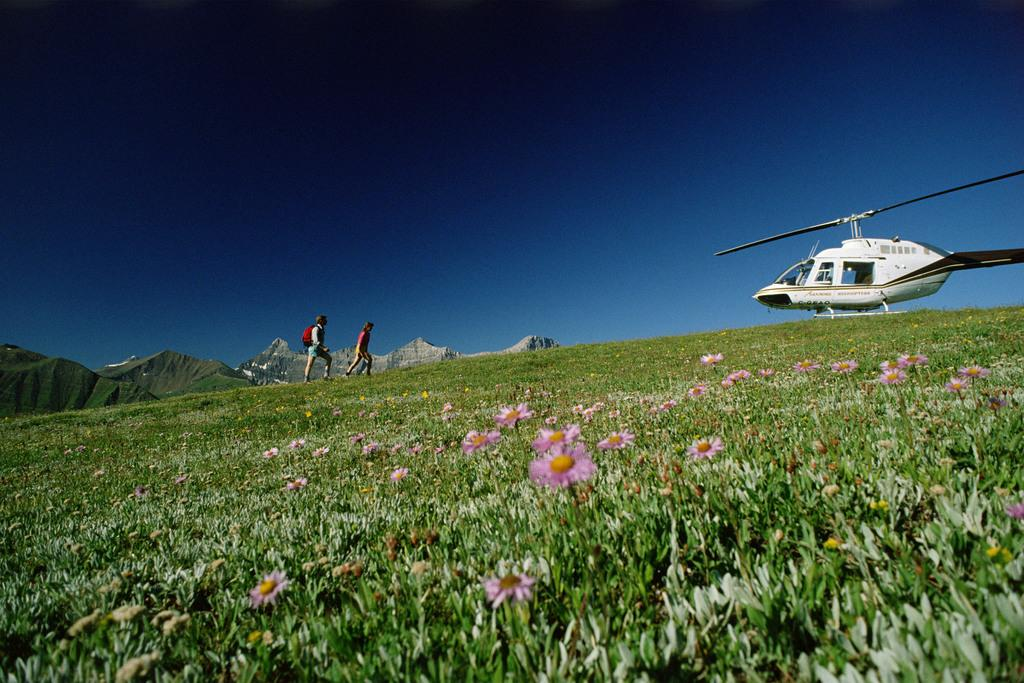What type of plants can be seen in the image? There are flowers in the image. What mode of transportation is present in the image? There is a helicopter in the image. What are the two people in the image doing? They are on the grass in the image. What type of natural feature can be seen in the image? There are rocks in the image. What is visible in the background of the image? The sky is visible in the background of the image. What type of impulse can be seen affecting the helicopter in the image? There is no impulse affecting the helicopter in the image; it is stationary. What selection of trains is visible in the image? There are no trains present in the image. 